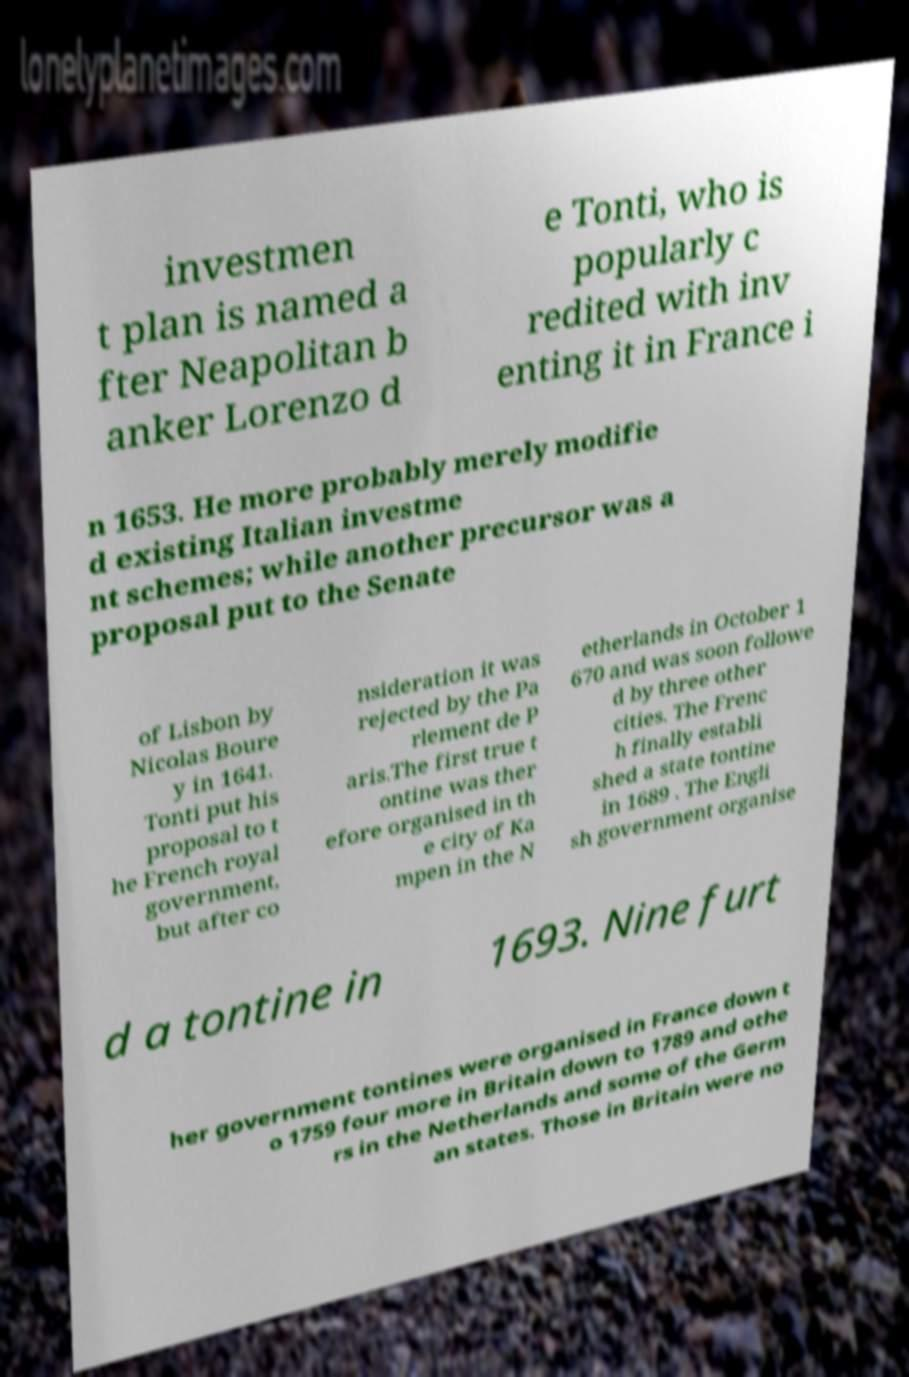For documentation purposes, I need the text within this image transcribed. Could you provide that? investmen t plan is named a fter Neapolitan b anker Lorenzo d e Tonti, who is popularly c redited with inv enting it in France i n 1653. He more probably merely modifie d existing Italian investme nt schemes; while another precursor was a proposal put to the Senate of Lisbon by Nicolas Boure y in 1641. Tonti put his proposal to t he French royal government, but after co nsideration it was rejected by the Pa rlement de P aris.The first true t ontine was ther efore organised in th e city of Ka mpen in the N etherlands in October 1 670 and was soon followe d by three other cities. The Frenc h finally establi shed a state tontine in 1689 . The Engli sh government organise d a tontine in 1693. Nine furt her government tontines were organised in France down t o 1759 four more in Britain down to 1789 and othe rs in the Netherlands and some of the Germ an states. Those in Britain were no 